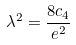Convert formula to latex. <formula><loc_0><loc_0><loc_500><loc_500>\lambda ^ { 2 } = \frac { 8 c _ { 4 } } { e ^ { 2 } }</formula> 